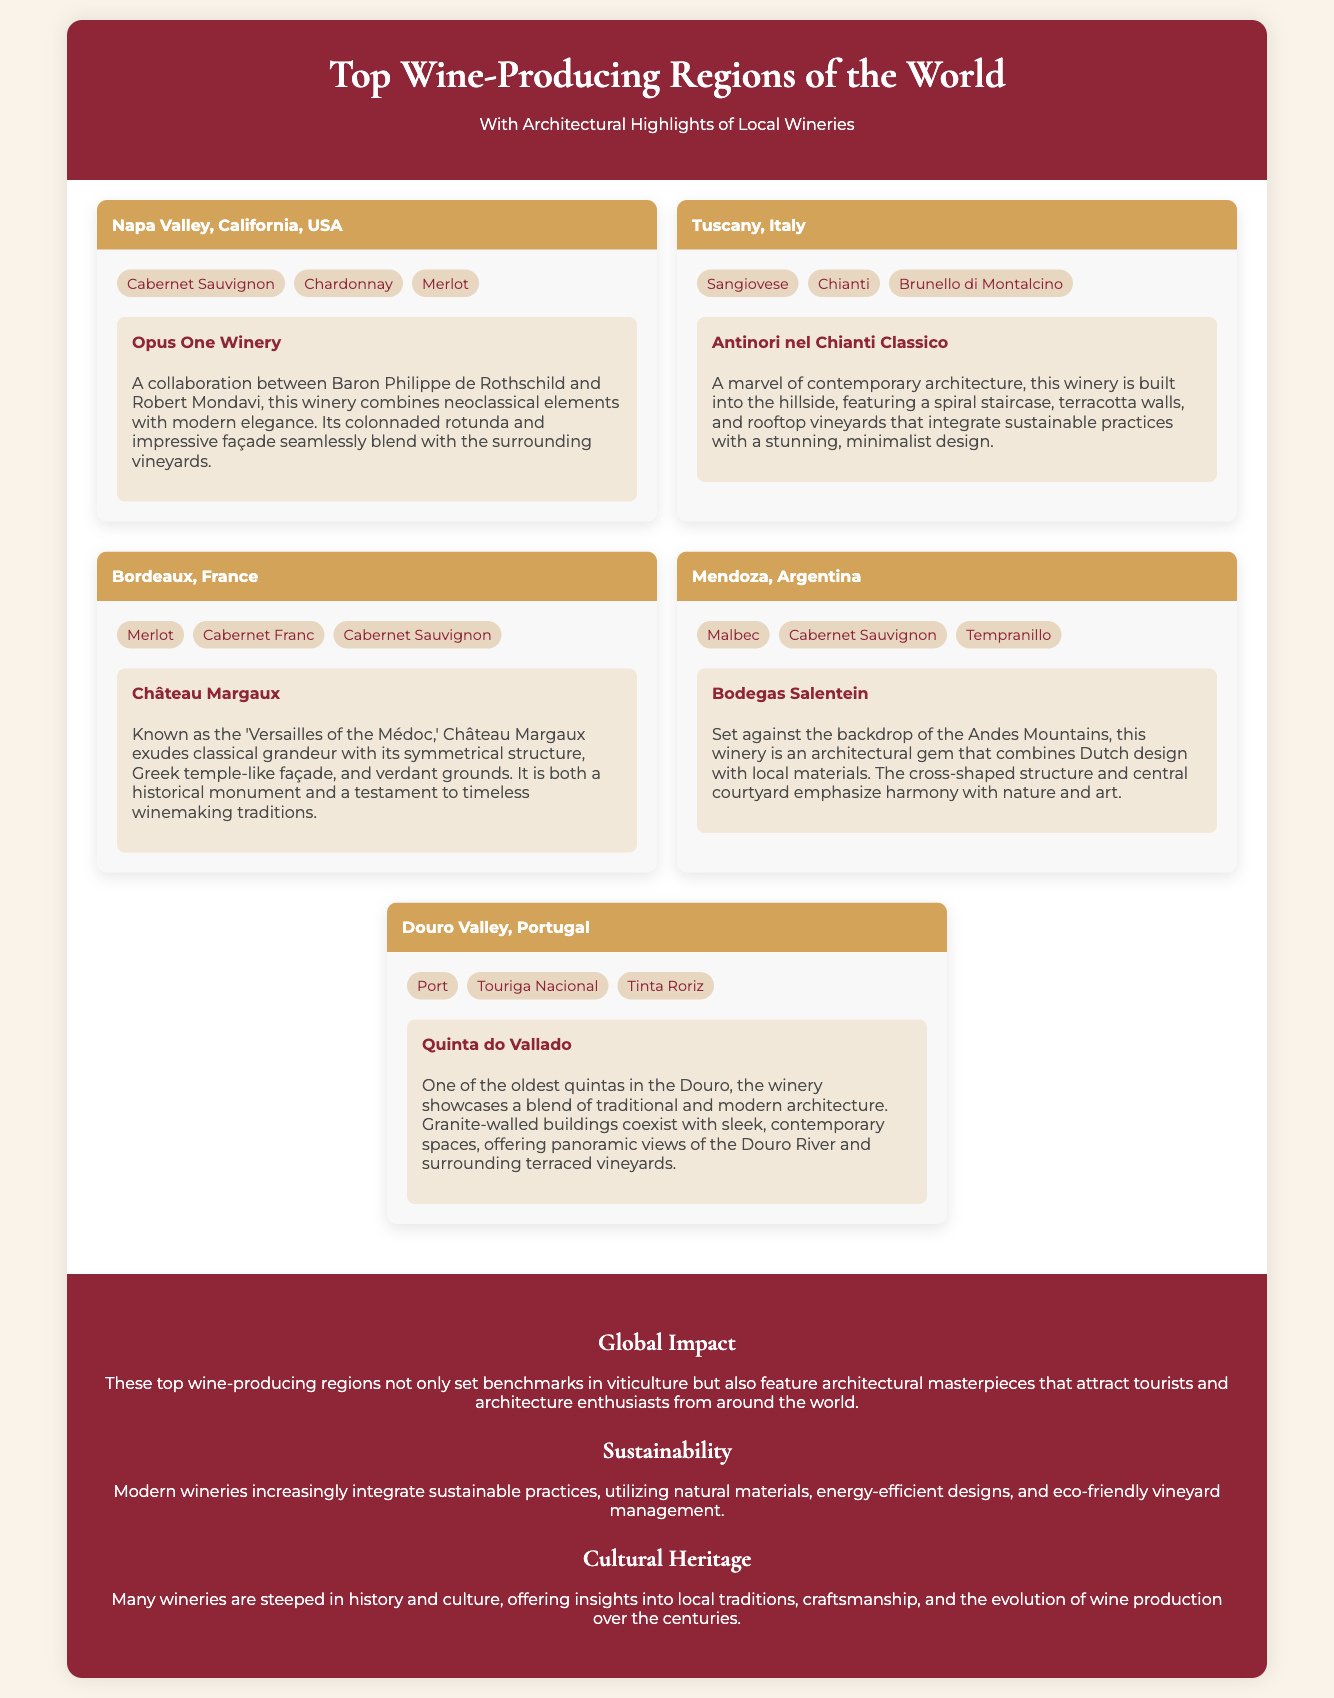What are the top wine varieties produced in Napa Valley? The document lists Cabernet Sauvignon, Chardonnay, and Merlot as the top wine varieties for Napa Valley.
Answer: Cabernet Sauvignon, Chardonnay, Merlot Which architectural feature is highlighted for Opus One Winery? The document mentions its colonnaded rotunda and impressive façade as key architectural features of Opus One Winery.
Answer: Colonnaded rotunda, impressive façade What is the architectural style of Antinori nel Chianti Classico? The winery is described as a marvel of contemporary architecture, built into the hillside with a minimalist design.
Answer: Contemporary architecture, minimalist design How many wine varieties are listed for Mendoza, Argentina? The document lists three wine varieties for Mendoza: Malbec, Cabernet Sauvignon, and Tempranillo.
Answer: Three What region is known as the "Versailles of the Médoc"? Château Margaux is referred to as the 'Versailles of the Médoc' in the document due to its classical grandeur.
Answer: Château Margaux What is a significant feature of Quinta do Vallado's architecture? The document highlights the blend of traditional and modern architecture at Quinta do Vallado, showcasing granite-walled buildings.
Answer: Blend of traditional and modern architecture What overall benefit do the top wine-producing regions provide, according to the document? The document states that these regions not only set benchmarks in viticulture but also attract tourists and architecture enthusiasts.
Answer: Attract tourists and architecture enthusiasts Which winery integrates sustainable practices into its design? The description of Antinori nel Chianti Classico indicates its integration of sustainable practices with its architectural features.
Answer: Antinori nel Chianti Classico What wine variety is unique to Tuscany among the regions listed? The document mentions Sangiovese as a specific wine variety associated solely with Tuscany.
Answer: Sangiovese 